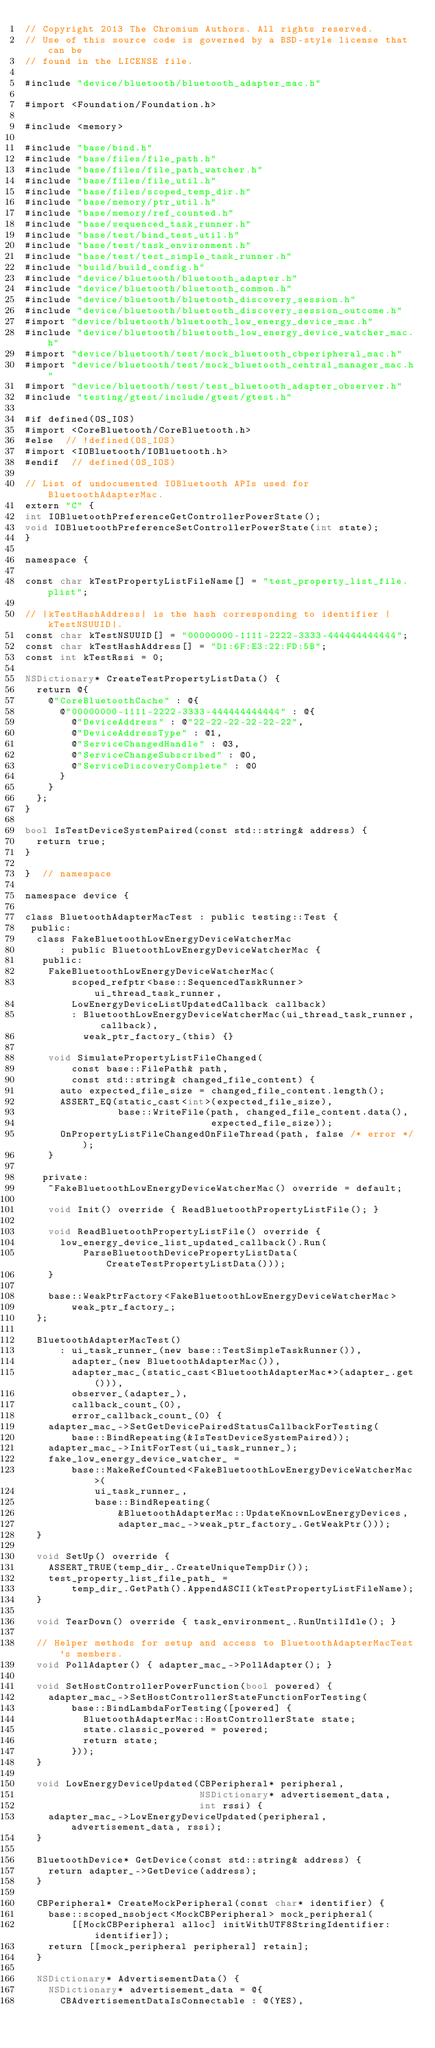<code> <loc_0><loc_0><loc_500><loc_500><_ObjectiveC_>// Copyright 2013 The Chromium Authors. All rights reserved.
// Use of this source code is governed by a BSD-style license that can be
// found in the LICENSE file.

#include "device/bluetooth/bluetooth_adapter_mac.h"

#import <Foundation/Foundation.h>

#include <memory>

#include "base/bind.h"
#include "base/files/file_path.h"
#include "base/files/file_path_watcher.h"
#include "base/files/file_util.h"
#include "base/files/scoped_temp_dir.h"
#include "base/memory/ptr_util.h"
#include "base/memory/ref_counted.h"
#include "base/sequenced_task_runner.h"
#include "base/test/bind_test_util.h"
#include "base/test/task_environment.h"
#include "base/test/test_simple_task_runner.h"
#include "build/build_config.h"
#include "device/bluetooth/bluetooth_adapter.h"
#include "device/bluetooth/bluetooth_common.h"
#include "device/bluetooth/bluetooth_discovery_session.h"
#include "device/bluetooth/bluetooth_discovery_session_outcome.h"
#import "device/bluetooth/bluetooth_low_energy_device_mac.h"
#include "device/bluetooth/bluetooth_low_energy_device_watcher_mac.h"
#import "device/bluetooth/test/mock_bluetooth_cbperipheral_mac.h"
#import "device/bluetooth/test/mock_bluetooth_central_manager_mac.h"
#import "device/bluetooth/test/test_bluetooth_adapter_observer.h"
#include "testing/gtest/include/gtest/gtest.h"

#if defined(OS_IOS)
#import <CoreBluetooth/CoreBluetooth.h>
#else  // !defined(OS_IOS)
#import <IOBluetooth/IOBluetooth.h>
#endif  // defined(OS_IOS)

// List of undocumented IOBluetooth APIs used for BluetoothAdapterMac.
extern "C" {
int IOBluetoothPreferenceGetControllerPowerState();
void IOBluetoothPreferenceSetControllerPowerState(int state);
}

namespace {

const char kTestPropertyListFileName[] = "test_property_list_file.plist";

// |kTestHashAddress| is the hash corresponding to identifier |kTestNSUUID|.
const char kTestNSUUID[] = "00000000-1111-2222-3333-444444444444";
const char kTestHashAddress[] = "D1:6F:E3:22:FD:5B";
const int kTestRssi = 0;

NSDictionary* CreateTestPropertyListData() {
  return @{
    @"CoreBluetoothCache" : @{
      @"00000000-1111-2222-3333-444444444444" : @{
        @"DeviceAddress" : @"22-22-22-22-22-22",
        @"DeviceAddressType" : @1,
        @"ServiceChangedHandle" : @3,
        @"ServiceChangeSubscribed" : @0,
        @"ServiceDiscoveryComplete" : @0
      }
    }
  };
}

bool IsTestDeviceSystemPaired(const std::string& address) {
  return true;
}

}  // namespace

namespace device {

class BluetoothAdapterMacTest : public testing::Test {
 public:
  class FakeBluetoothLowEnergyDeviceWatcherMac
      : public BluetoothLowEnergyDeviceWatcherMac {
   public:
    FakeBluetoothLowEnergyDeviceWatcherMac(
        scoped_refptr<base::SequencedTaskRunner> ui_thread_task_runner,
        LowEnergyDeviceListUpdatedCallback callback)
        : BluetoothLowEnergyDeviceWatcherMac(ui_thread_task_runner, callback),
          weak_ptr_factory_(this) {}

    void SimulatePropertyListFileChanged(
        const base::FilePath& path,
        const std::string& changed_file_content) {
      auto expected_file_size = changed_file_content.length();
      ASSERT_EQ(static_cast<int>(expected_file_size),
                base::WriteFile(path, changed_file_content.data(),
                                expected_file_size));
      OnPropertyListFileChangedOnFileThread(path, false /* error */);
    }

   private:
    ~FakeBluetoothLowEnergyDeviceWatcherMac() override = default;

    void Init() override { ReadBluetoothPropertyListFile(); }

    void ReadBluetoothPropertyListFile() override {
      low_energy_device_list_updated_callback().Run(
          ParseBluetoothDevicePropertyListData(CreateTestPropertyListData()));
    }

    base::WeakPtrFactory<FakeBluetoothLowEnergyDeviceWatcherMac>
        weak_ptr_factory_;
  };

  BluetoothAdapterMacTest()
      : ui_task_runner_(new base::TestSimpleTaskRunner()),
        adapter_(new BluetoothAdapterMac()),
        adapter_mac_(static_cast<BluetoothAdapterMac*>(adapter_.get())),
        observer_(adapter_),
        callback_count_(0),
        error_callback_count_(0) {
    adapter_mac_->SetGetDevicePairedStatusCallbackForTesting(
        base::BindRepeating(&IsTestDeviceSystemPaired));
    adapter_mac_->InitForTest(ui_task_runner_);
    fake_low_energy_device_watcher_ =
        base::MakeRefCounted<FakeBluetoothLowEnergyDeviceWatcherMac>(
            ui_task_runner_,
            base::BindRepeating(
                &BluetoothAdapterMac::UpdateKnownLowEnergyDevices,
                adapter_mac_->weak_ptr_factory_.GetWeakPtr()));
  }

  void SetUp() override {
    ASSERT_TRUE(temp_dir_.CreateUniqueTempDir());
    test_property_list_file_path_ =
        temp_dir_.GetPath().AppendASCII(kTestPropertyListFileName);
  }

  void TearDown() override { task_environment_.RunUntilIdle(); }

  // Helper methods for setup and access to BluetoothAdapterMacTest's members.
  void PollAdapter() { adapter_mac_->PollAdapter(); }

  void SetHostControllerPowerFunction(bool powered) {
    adapter_mac_->SetHostControllerStateFunctionForTesting(
        base::BindLambdaForTesting([powered] {
          BluetoothAdapterMac::HostControllerState state;
          state.classic_powered = powered;
          return state;
        }));
  }

  void LowEnergyDeviceUpdated(CBPeripheral* peripheral,
                              NSDictionary* advertisement_data,
                              int rssi) {
    adapter_mac_->LowEnergyDeviceUpdated(peripheral, advertisement_data, rssi);
  }

  BluetoothDevice* GetDevice(const std::string& address) {
    return adapter_->GetDevice(address);
  }

  CBPeripheral* CreateMockPeripheral(const char* identifier) {
    base::scoped_nsobject<MockCBPeripheral> mock_peripheral(
        [[MockCBPeripheral alloc] initWithUTF8StringIdentifier:identifier]);
    return [[mock_peripheral peripheral] retain];
  }

  NSDictionary* AdvertisementData() {
    NSDictionary* advertisement_data = @{
      CBAdvertisementDataIsConnectable : @(YES),</code> 